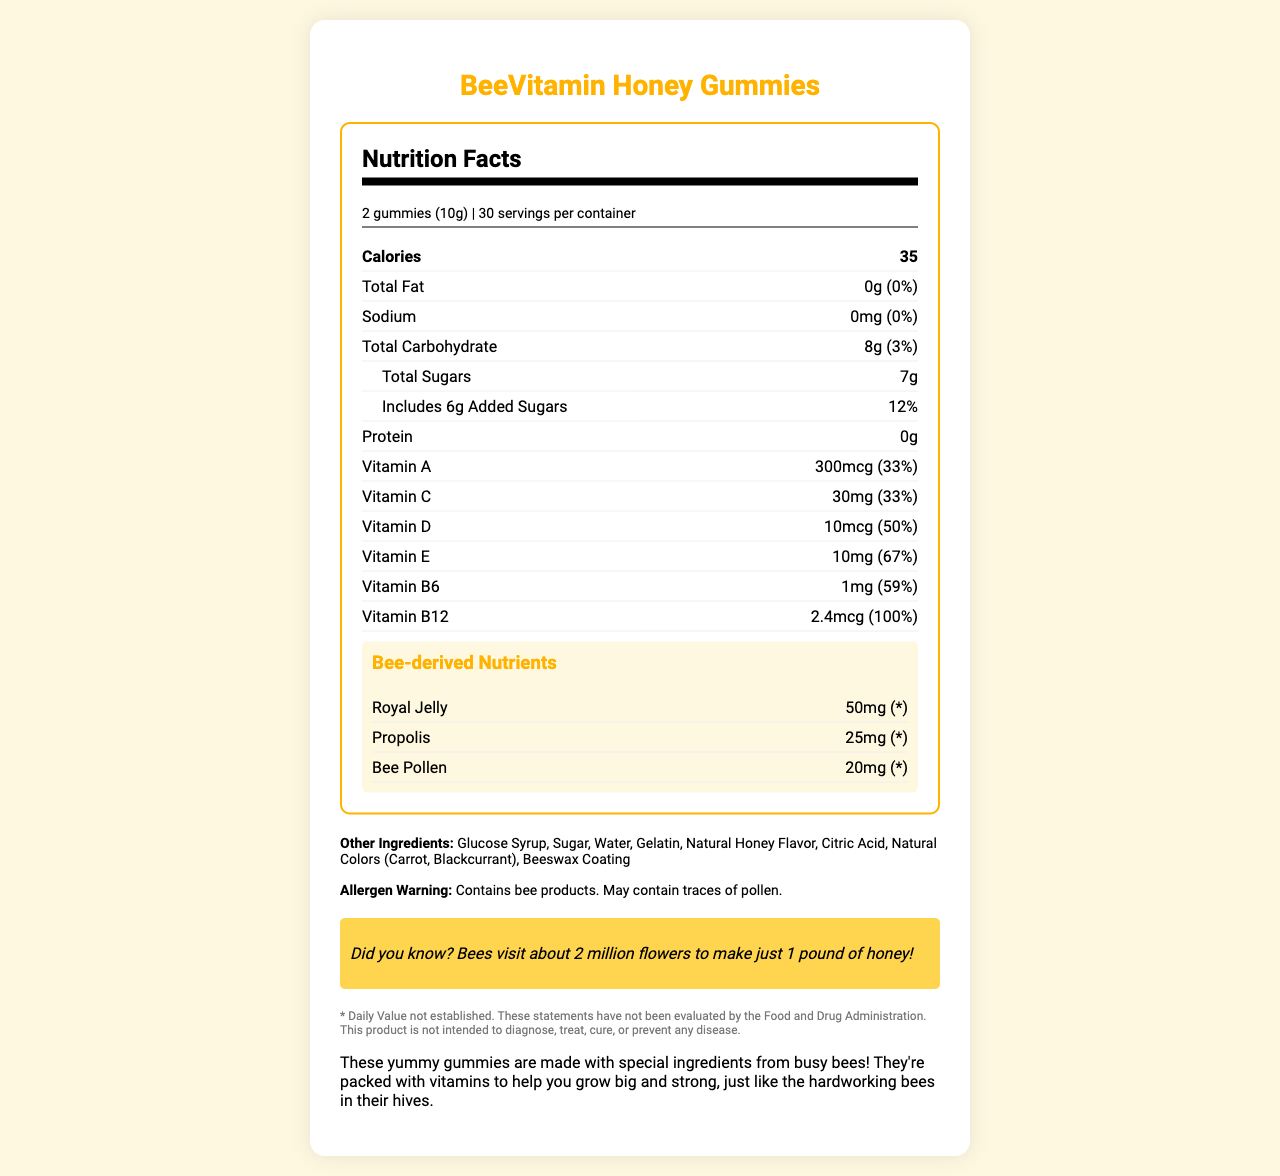what is the serving size? The serving size is mentioned at the beginning of the Nutrition Facts section.
Answer: 2 gummies (10g) how many servings are there per container? The number of servings per container is indicated right after the serving size.
Answer: 30 how many calories are there per serving? The number of calories per serving is listed prominently in the main Nutrition Facts section.
Answer: 35 how much total fat is in a serving? The total fat content per serving is shown in the Nutrition Facts, next to the total fat label.
Answer: 0g (0%) how much vitamin D is in a serving? The vitamin D content per serving is listed under the vitamins section in the Nutrition Facts.
Answer: 10mcg (50%) how much added sugars are in each serving? The amount of added sugars is indicated under the total carbohydrate section.
Answer: 6g (12%) which vitamin has the highest percentage daily value in a serving? The daily value percentages for each vitamin can be found under their respective labels, with Vitamin B12 having the highest at 100%.
Answer: Vitamin B12 (100%) which of the following items is NOT an ingredient in the BeeVitamin Honey Gummies? A. Gelatin B. Citric Acid C. Artificial Flavors The "Other Ingredients" section lists all the ingredients, and Artificial Flavors is not included.
Answer: C how many grams of protein are in a serving? A. 0g B. 1g C. 2g D. 5g The amount of protein per serving is indicated as 0g in the Nutrition Facts.
Answer: A which of the following nutrients is derived from bees? I. Royal Jelly II. Propolis III. Bee Pollen All three, Royal Jelly, Propolis, and Bee Pollen, are listed under the bee-derived nutrients section.
Answer: I, II, III is there any allergen warning for BeeVitamin Honey Gummies? There is an allergen warning stating that the product contains bee products and may contain traces of pollen.
Answer: Yes summarize the main idea of the document. The document includes a detailed breakdown of nutrients, highlighting how these gummies are inspired by bee-related components, and providing additional information such as allergen warnings, other ingredients, and a fun fact.
Answer: The BeeVitamin Honey Gummies Nutrition Facts Label provides detailed information on the nutrition content, including key vitamins and bee-derived nutrients, along with other ingredients, an allergen warning, a fun fact about bees, and a description highlighting the benefits and nature of the gummies. how many milligrams of propolis are in a single serving of BeeVitamin Honey Gummies? The amount of propolis per serving is listed under the bee-derived nutrients section.
Answer: 25mg can we determine the total cost of the BeeVitamin Honey Gummies from the document? The document does not provide any information regarding the price or cost of the BeeVitamin Honey Gummies.
Answer: No 